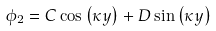Convert formula to latex. <formula><loc_0><loc_0><loc_500><loc_500>\phi _ { 2 } = C \cos \left ( \kappa y \right ) + D \sin \left ( \kappa y \right )</formula> 